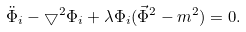<formula> <loc_0><loc_0><loc_500><loc_500>\ddot { \Phi } _ { i } - \bigtriangledown ^ { 2 } \Phi _ { i } + \lambda \Phi _ { i } ( \vec { \Phi } ^ { 2 } - m ^ { 2 } ) = 0 .</formula> 